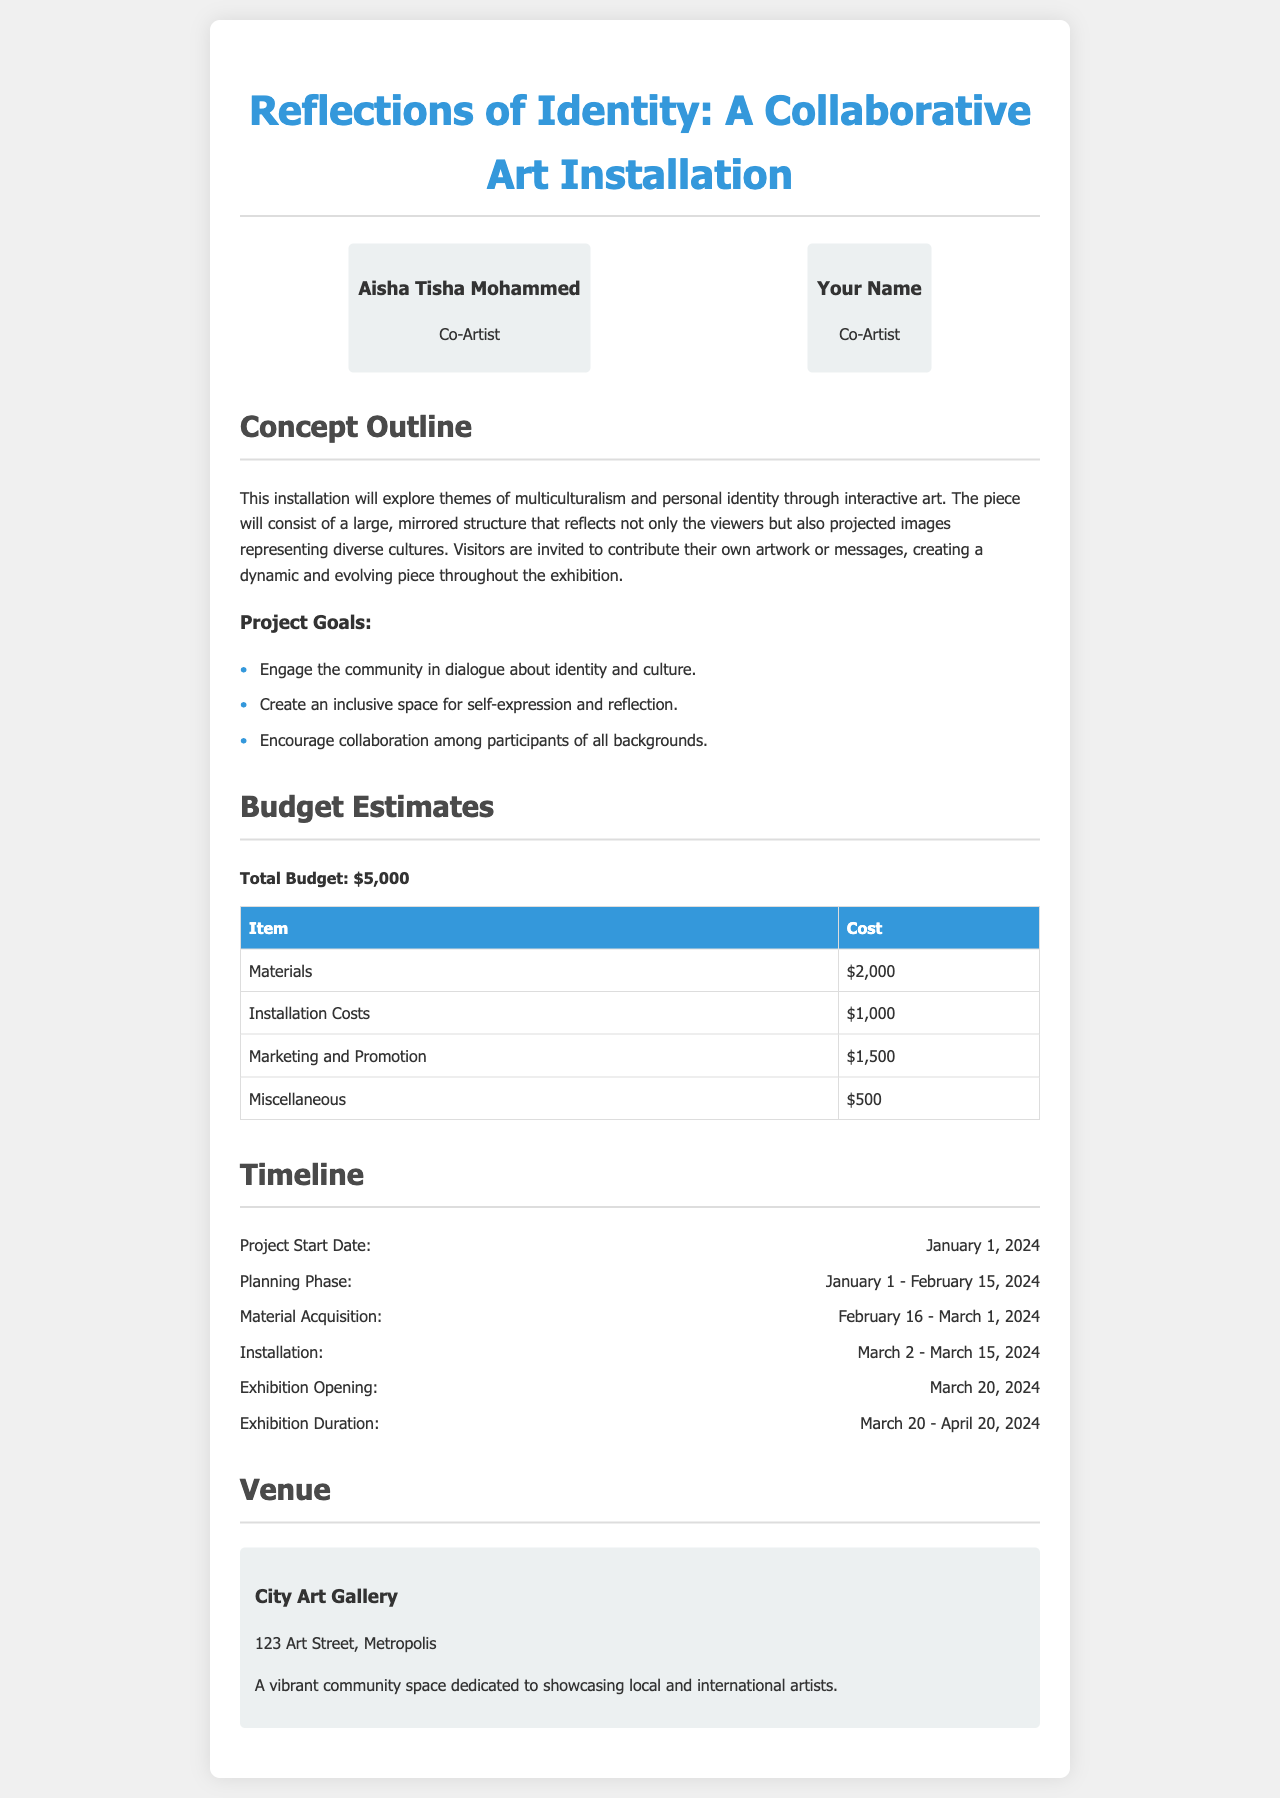What is the title of the installation? The title of the installation is found in the heading of the proposal.
Answer: Reflections of Identity: A Collaborative Art Installation Who are the collaborators? The collaborators' names are listed together with their roles in the document.
Answer: Aisha Tisha Mohammed and Your Name What is the total budget for the project? The total budget is stated clearly in the budget section.
Answer: $5,000 What is the installation cost? This cost is detailed in the budget table under installation costs.
Answer: $1,000 When does the exhibition opening occur? The exhibition opening date is mentioned in the timeline section.
Answer: March 20, 2024 What venue will the installation take place in? The venue is specified in the venue section of the document.
Answer: City Art Gallery What theme does the installation explore? The theme can be found in the concept outline section.
Answer: Multiculturalism and personal identity How long will the exhibition last? The duration of the exhibition is indicated in the timeline.
Answer: March 20 - April 20, 2024 What item has the highest cost in the budget? The item with the highest cost can be identified by reviewing the budget table.
Answer: Materials 